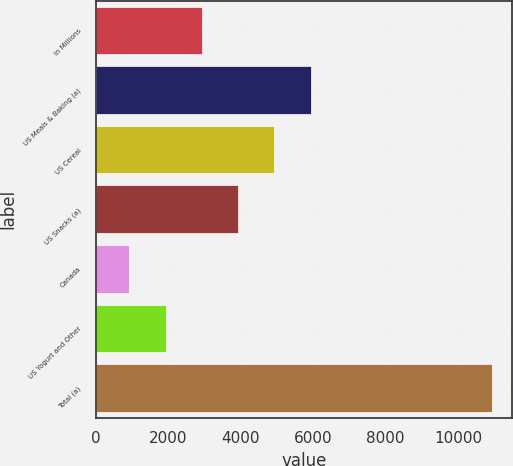<chart> <loc_0><loc_0><loc_500><loc_500><bar_chart><fcel>In Millions<fcel>US Meals & Baking (a)<fcel>US Cereal<fcel>US Snacks (a)<fcel>Canada<fcel>US Yogurt and Other<fcel>Total (a)<nl><fcel>2930.92<fcel>5933.05<fcel>4932.34<fcel>3931.63<fcel>929.5<fcel>1930.21<fcel>10936.6<nl></chart> 